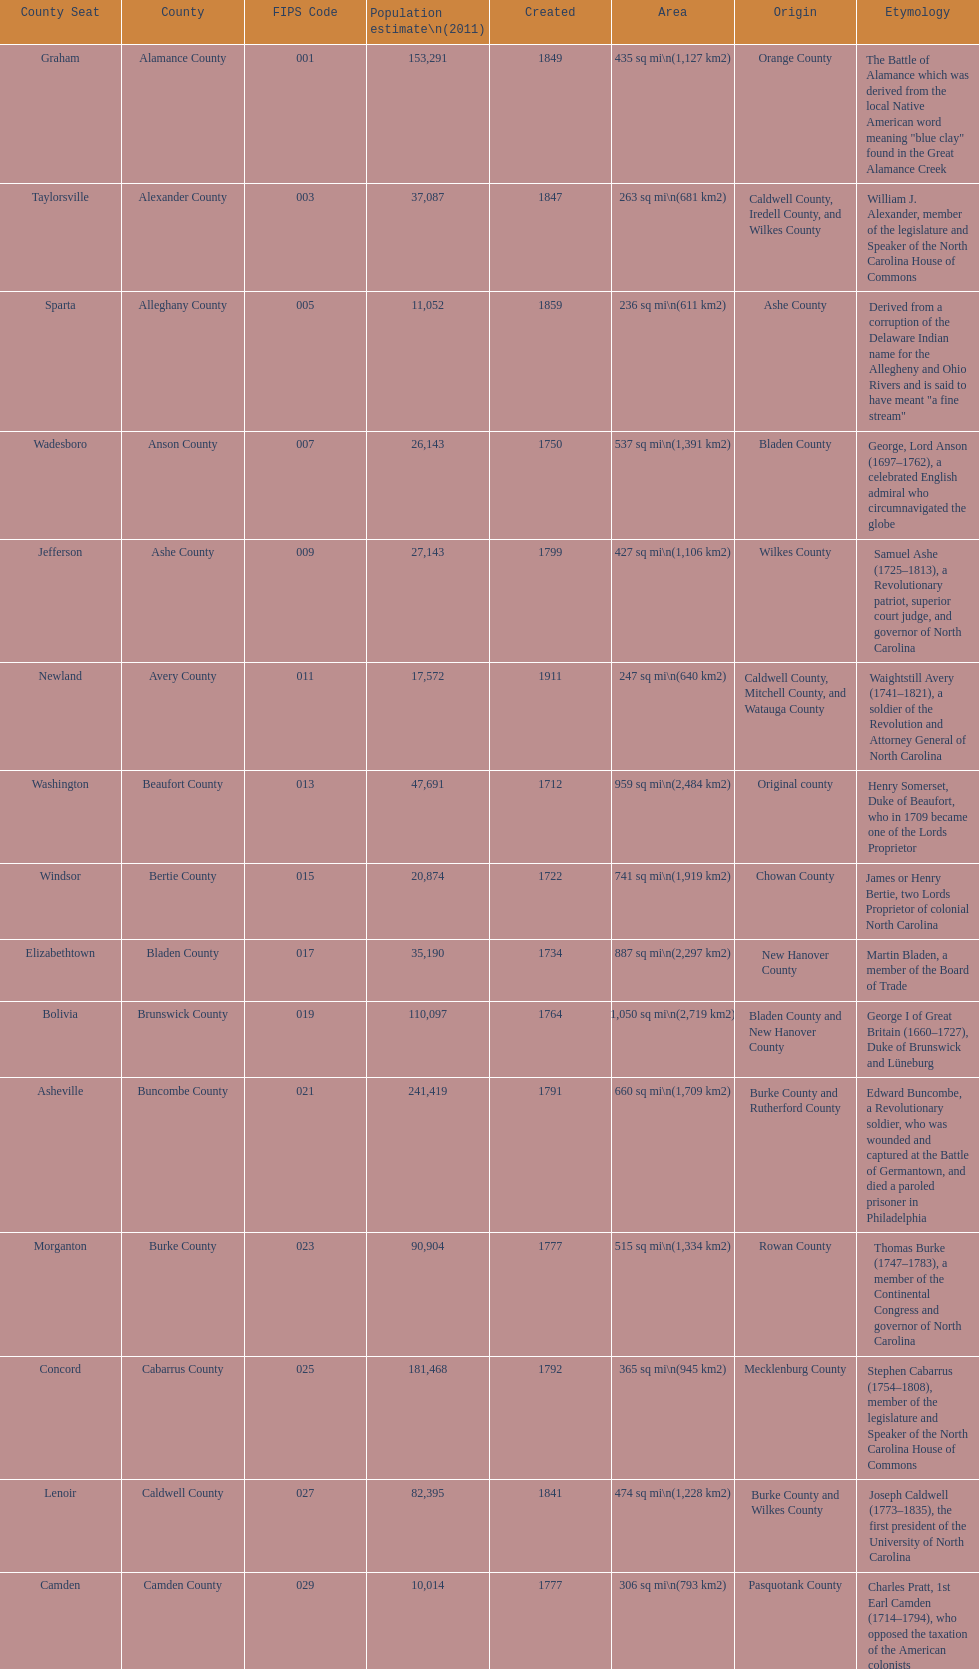Which county covers the most area? Dare County. 